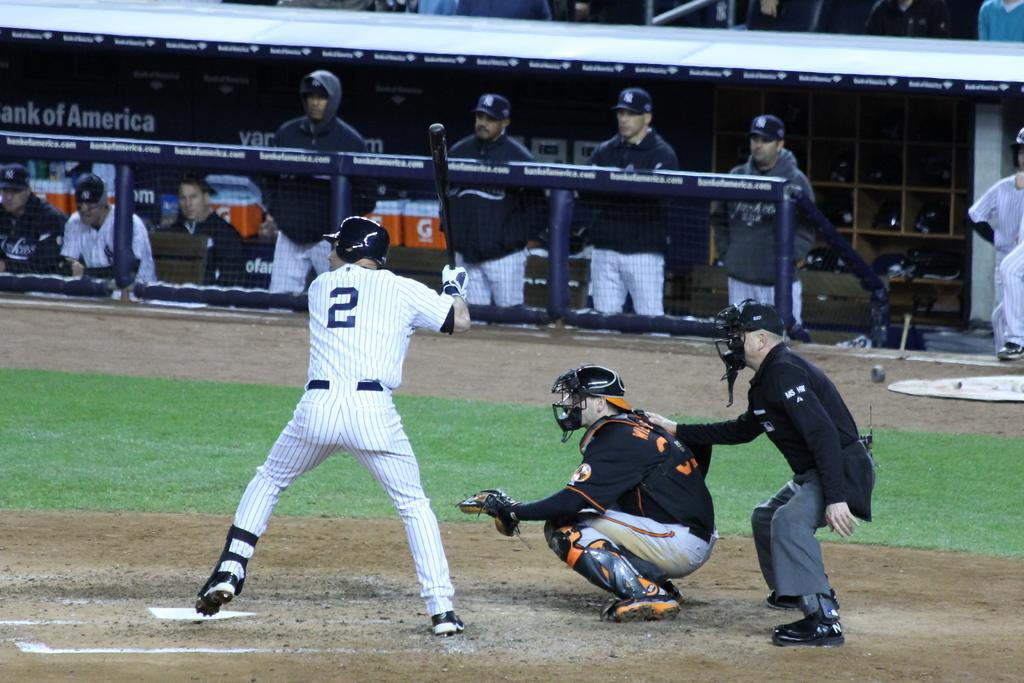Provide a one-sentence caption for the provided image. Baseball player number 2 is getting ready to bat in a stadium that has Bank of America as a sponsor. 